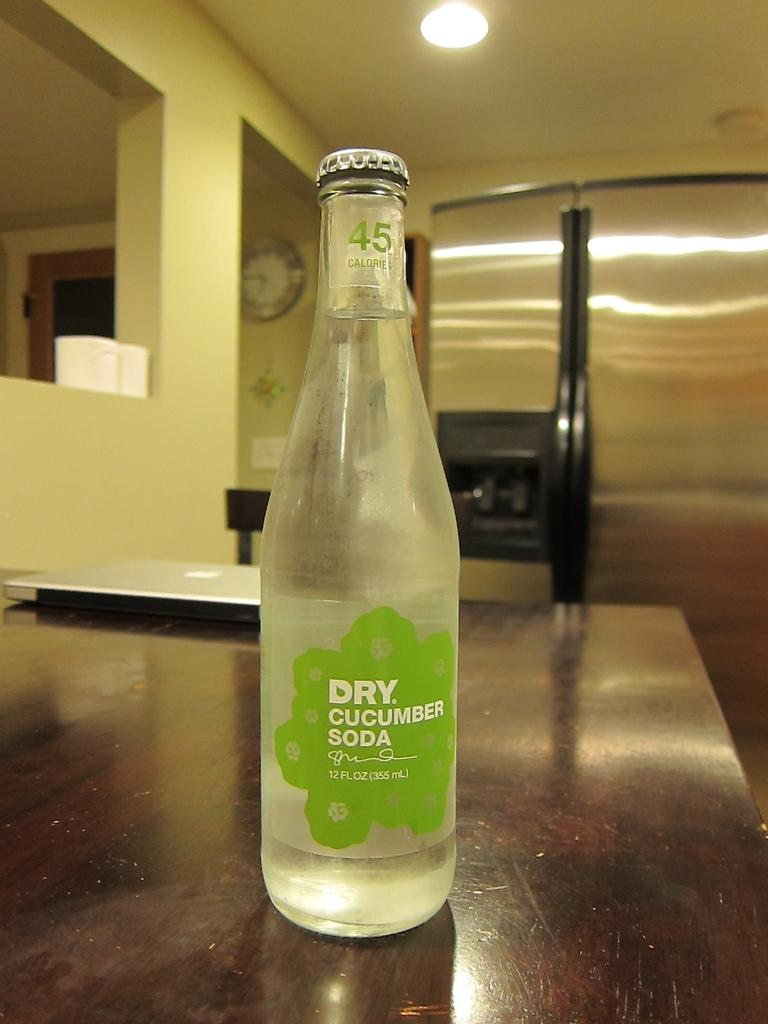Provide a one-sentence caption for the provided image. A bottle of Dry Cucumber Soda sits on a counter near a laptop. 